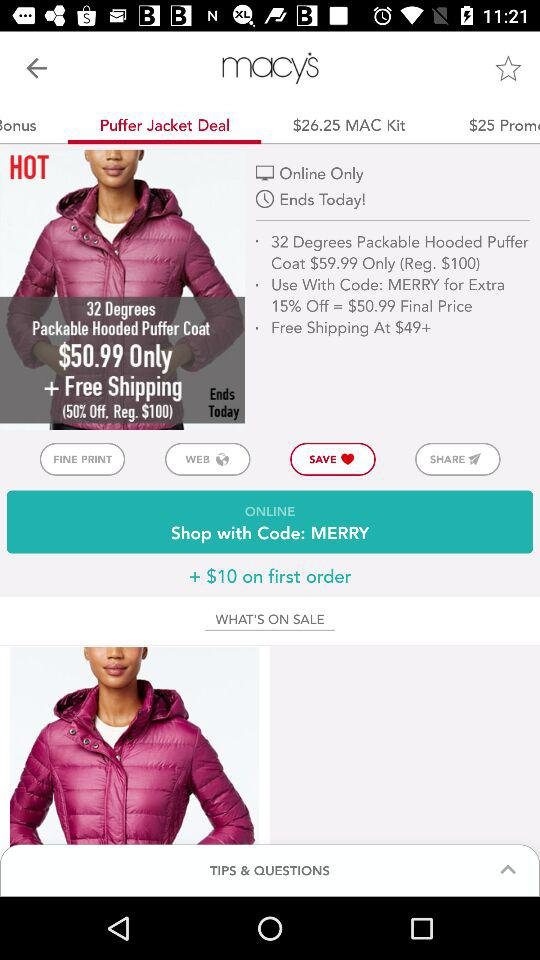What is the regular price of the "32 Degrees Packable Hooded Puffer Coat"? The regular price is $100. 